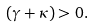<formula> <loc_0><loc_0><loc_500><loc_500>( \gamma + \kappa ) > 0 .</formula> 